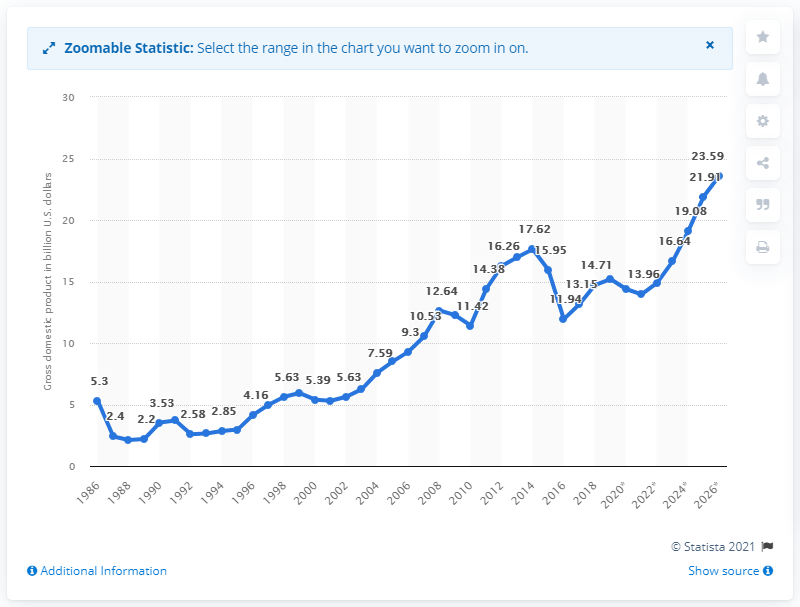Give some essential details in this illustration. According to the latest statistics, the gross domestic product of Mozambique in 2019 was 15.2. 